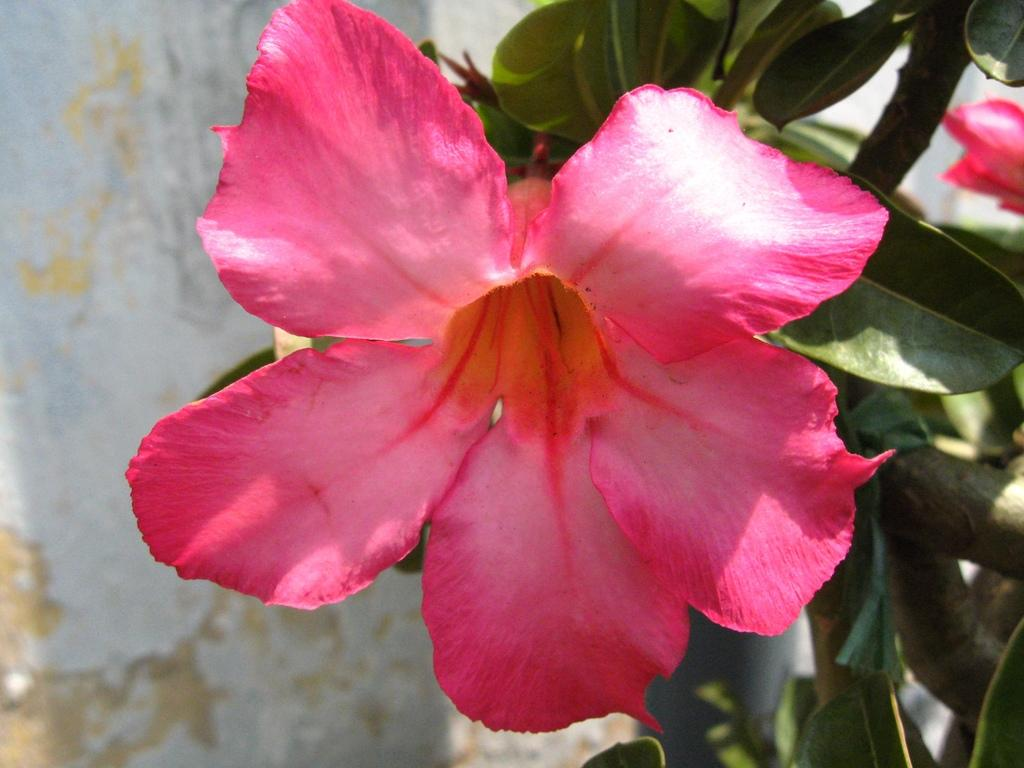What is the main subject in the foreground of the image? There is a flower in the foreground of the image. What other elements can be seen on the right side of the image? There are leaves and a flower on the right side of the image. What structure is located on the left side of the image? There is a well on the left side of the image. How many laborers are working in the well in the image? There are no laborers or wells in the image; it features a flower in the foreground and a well on the left side. What type of account is being kept by the worm in the image? There are no worms or accounts present in the image. 